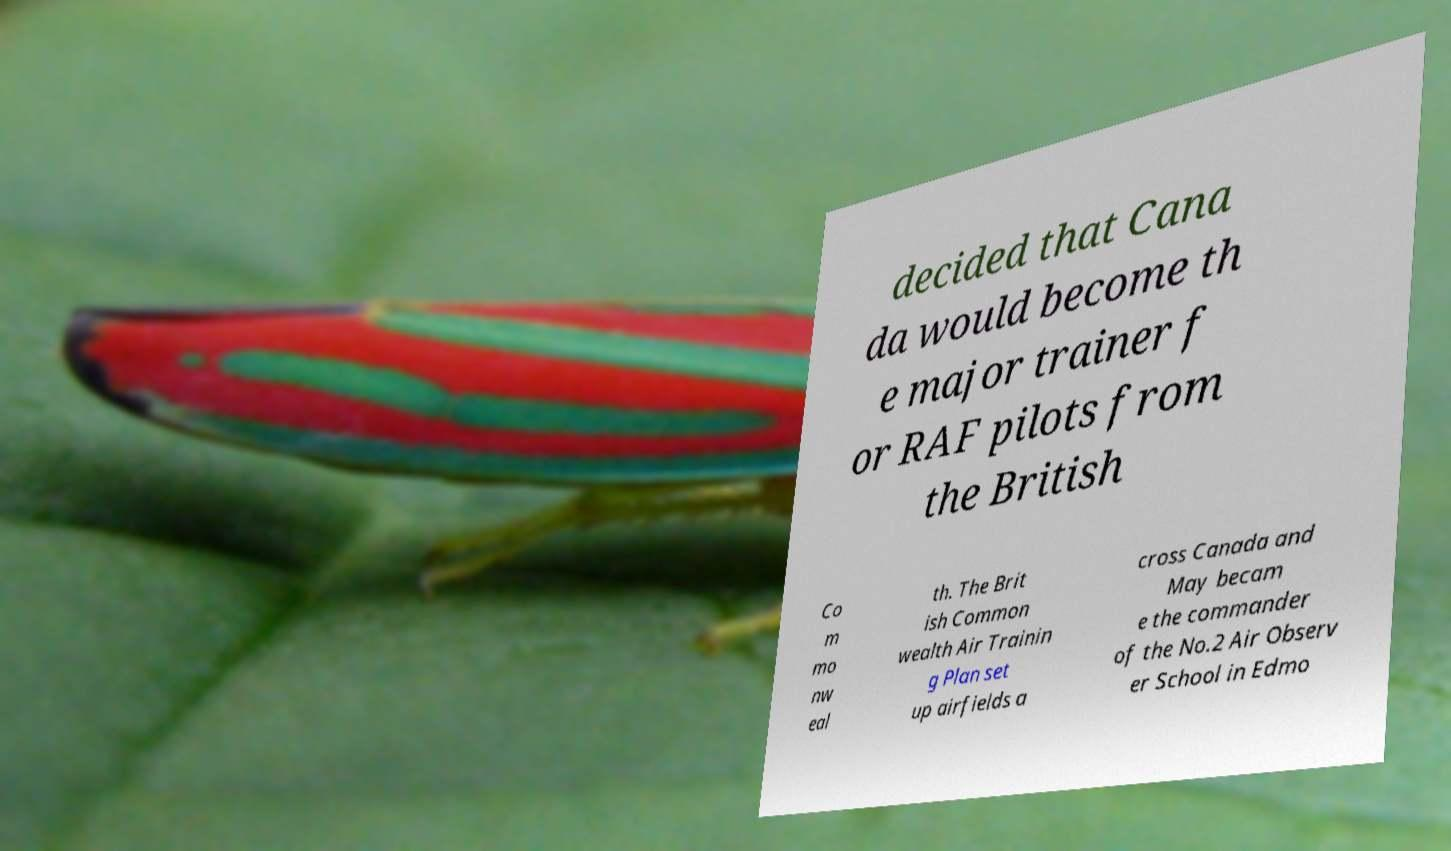I need the written content from this picture converted into text. Can you do that? decided that Cana da would become th e major trainer f or RAF pilots from the British Co m mo nw eal th. The Brit ish Common wealth Air Trainin g Plan set up airfields a cross Canada and May becam e the commander of the No.2 Air Observ er School in Edmo 